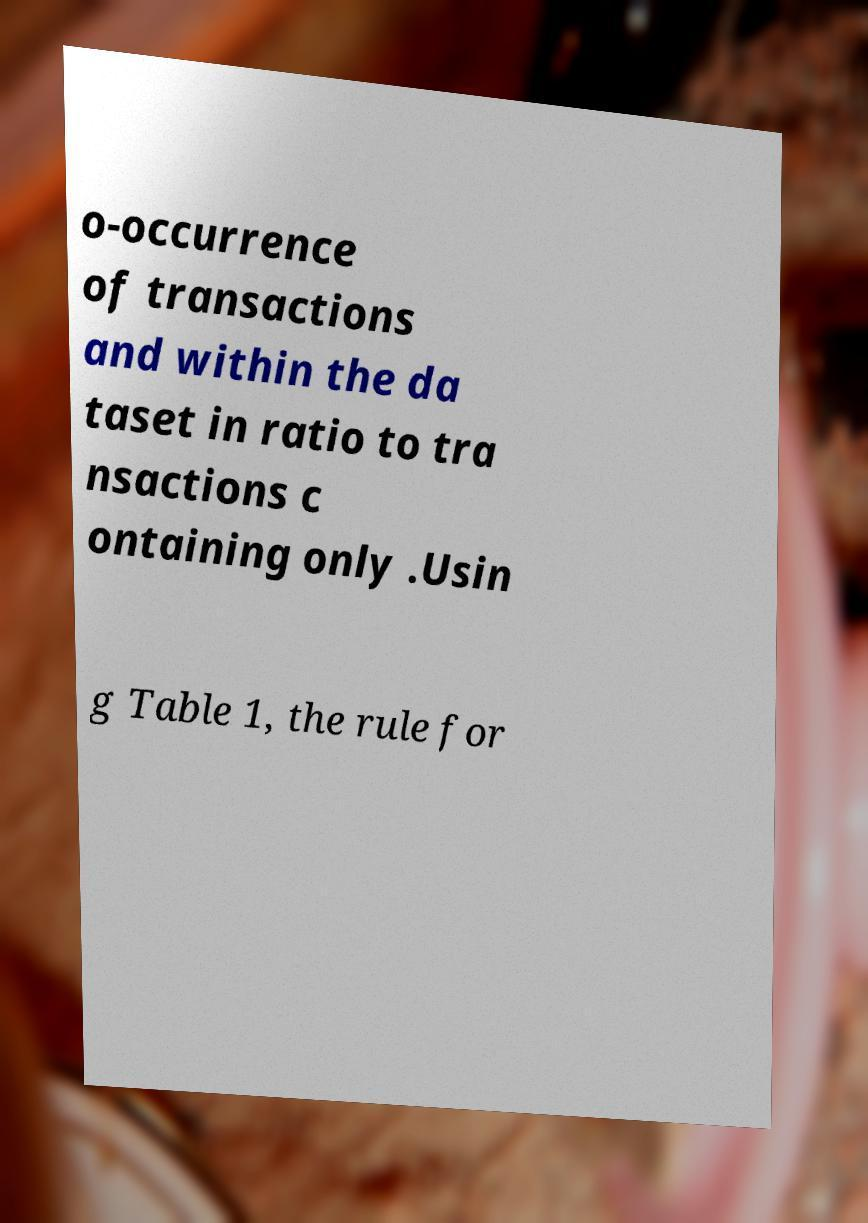Can you read and provide the text displayed in the image?This photo seems to have some interesting text. Can you extract and type it out for me? o-occurrence of transactions and within the da taset in ratio to tra nsactions c ontaining only .Usin g Table 1, the rule for 